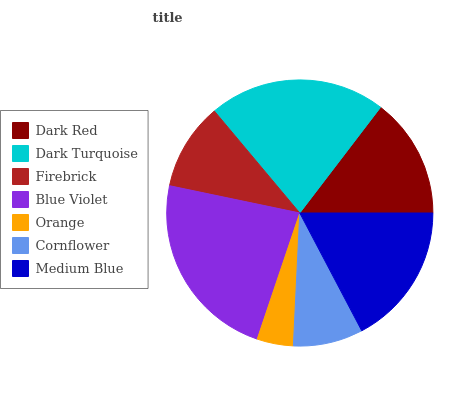Is Orange the minimum?
Answer yes or no. Yes. Is Blue Violet the maximum?
Answer yes or no. Yes. Is Dark Turquoise the minimum?
Answer yes or no. No. Is Dark Turquoise the maximum?
Answer yes or no. No. Is Dark Turquoise greater than Dark Red?
Answer yes or no. Yes. Is Dark Red less than Dark Turquoise?
Answer yes or no. Yes. Is Dark Red greater than Dark Turquoise?
Answer yes or no. No. Is Dark Turquoise less than Dark Red?
Answer yes or no. No. Is Dark Red the high median?
Answer yes or no. Yes. Is Dark Red the low median?
Answer yes or no. Yes. Is Cornflower the high median?
Answer yes or no. No. Is Blue Violet the low median?
Answer yes or no. No. 